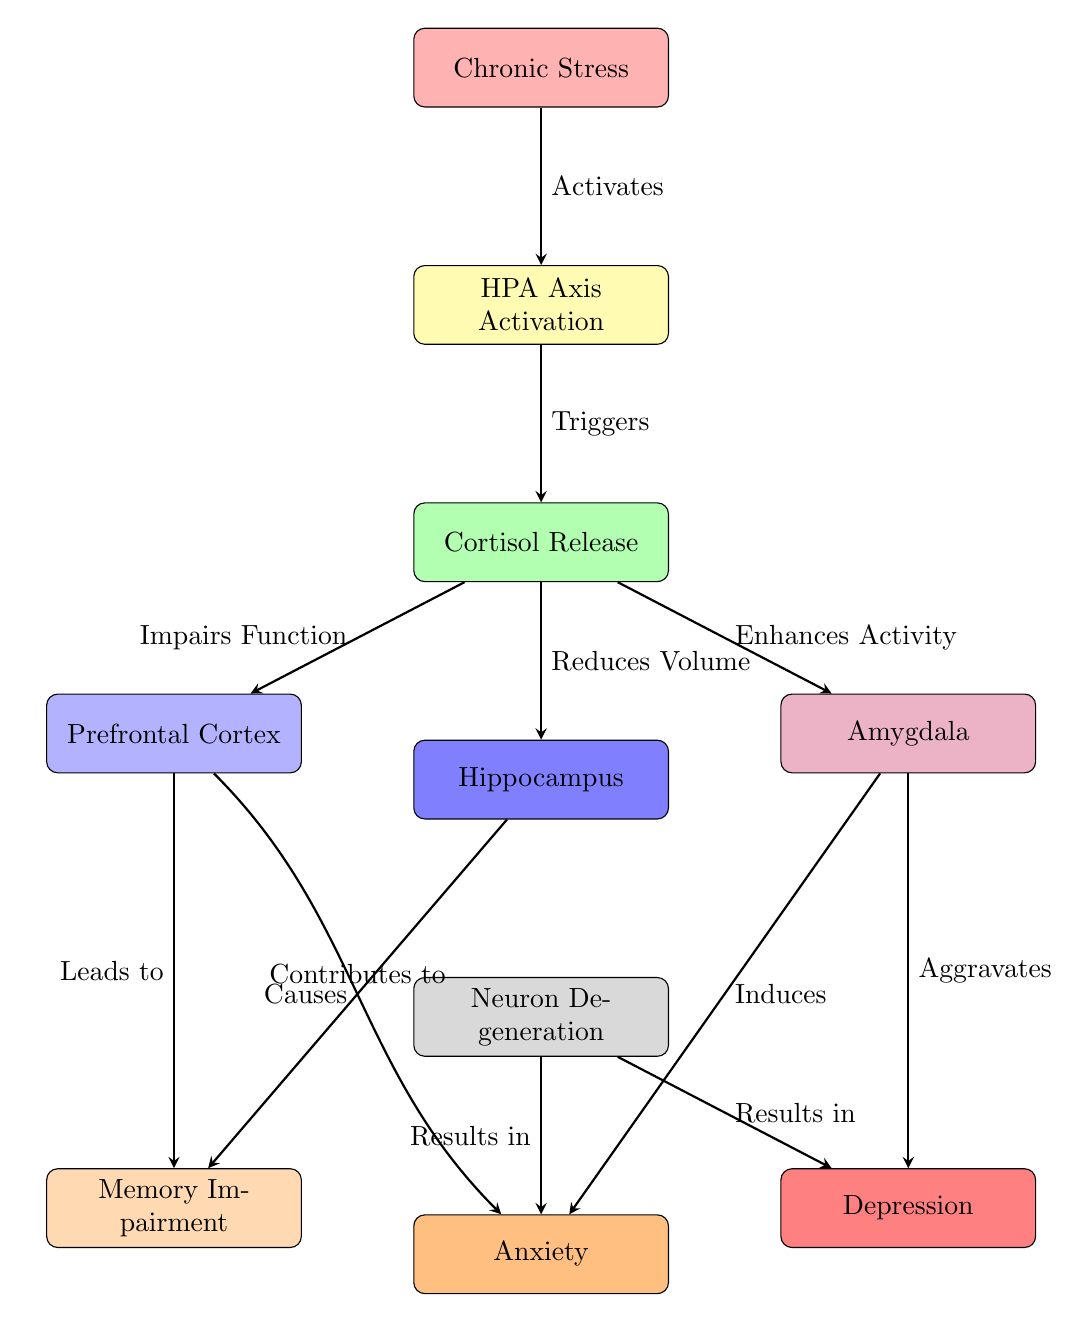What is the first node in the diagram? The diagram begins with the node labeled "Chronic Stress," which is the starting point of the flow.
Answer: Chronic Stress How many total nodes are in the diagram? By counting each process shape in the diagram, there are eight nodes representing different stages and effects.
Answer: 8 Which node is affected by cortisol release? The node labeled "Hippocampus" is directly affected as it states "Reduces Volume" due to cortisol release.
Answer: Hippocampus What effect does the Prefrontal Cortex have on memory? The arrow from the Prefrontal Cortex to the memory node states "Leads to," indicating a positive effect on memory function.
Answer: Leads to What is the relationship between the amygdala and depression? The diagram indicates that the amygdala "Aggravates" depression, showing a negative relationship impacting mental health.
Answer: Aggravates What causes memory impairment according to the diagram? Memory impairment is shown as a result of the Prefrontal Cortex leading to memory issues, and the Hippocampus also causes memory impairment.
Answer: Prefrontal Cortex and Hippocampus How do neurons relate to anxiety? Neuron degeneration results in anxiety as indicated by the arrow labeled "Results in" pointing towards the anxiety node from the neuron node.
Answer: Results in Which effect enhances the activity of the amygdala? The diagram specifies that "Cortisol Release" enhances amygdala activity, linking chronic stress to heightened emotional response.
Answer: Cortisol Release What is the last node in the diagram? The last node in the flow is "Depression," which is the final effect indicated after neuron degeneration impacts mental health.
Answer: Depression 